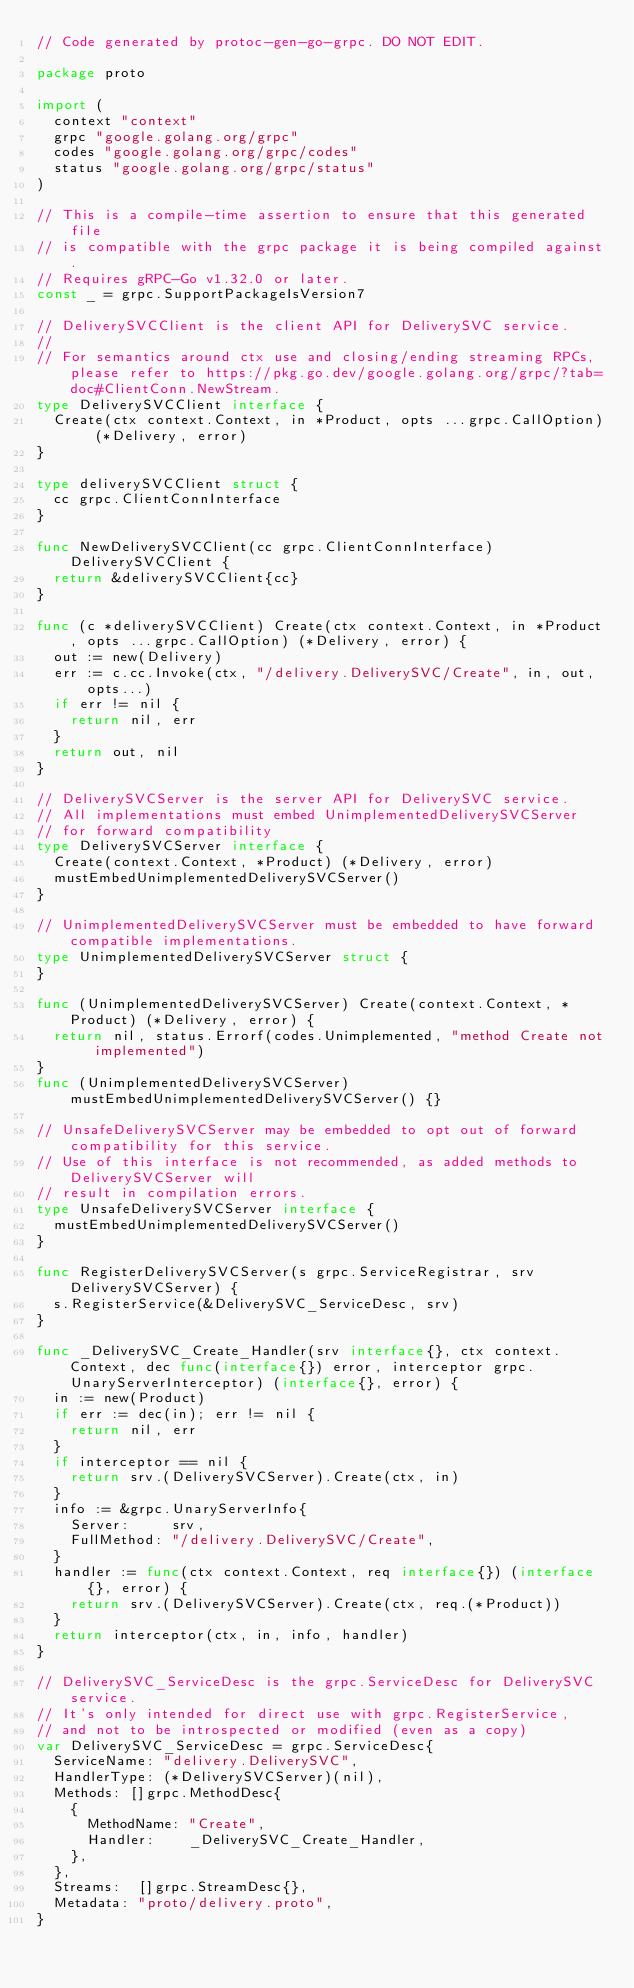Convert code to text. <code><loc_0><loc_0><loc_500><loc_500><_Go_>// Code generated by protoc-gen-go-grpc. DO NOT EDIT.

package proto

import (
	context "context"
	grpc "google.golang.org/grpc"
	codes "google.golang.org/grpc/codes"
	status "google.golang.org/grpc/status"
)

// This is a compile-time assertion to ensure that this generated file
// is compatible with the grpc package it is being compiled against.
// Requires gRPC-Go v1.32.0 or later.
const _ = grpc.SupportPackageIsVersion7

// DeliverySVCClient is the client API for DeliverySVC service.
//
// For semantics around ctx use and closing/ending streaming RPCs, please refer to https://pkg.go.dev/google.golang.org/grpc/?tab=doc#ClientConn.NewStream.
type DeliverySVCClient interface {
	Create(ctx context.Context, in *Product, opts ...grpc.CallOption) (*Delivery, error)
}

type deliverySVCClient struct {
	cc grpc.ClientConnInterface
}

func NewDeliverySVCClient(cc grpc.ClientConnInterface) DeliverySVCClient {
	return &deliverySVCClient{cc}
}

func (c *deliverySVCClient) Create(ctx context.Context, in *Product, opts ...grpc.CallOption) (*Delivery, error) {
	out := new(Delivery)
	err := c.cc.Invoke(ctx, "/delivery.DeliverySVC/Create", in, out, opts...)
	if err != nil {
		return nil, err
	}
	return out, nil
}

// DeliverySVCServer is the server API for DeliverySVC service.
// All implementations must embed UnimplementedDeliverySVCServer
// for forward compatibility
type DeliverySVCServer interface {
	Create(context.Context, *Product) (*Delivery, error)
	mustEmbedUnimplementedDeliverySVCServer()
}

// UnimplementedDeliverySVCServer must be embedded to have forward compatible implementations.
type UnimplementedDeliverySVCServer struct {
}

func (UnimplementedDeliverySVCServer) Create(context.Context, *Product) (*Delivery, error) {
	return nil, status.Errorf(codes.Unimplemented, "method Create not implemented")
}
func (UnimplementedDeliverySVCServer) mustEmbedUnimplementedDeliverySVCServer() {}

// UnsafeDeliverySVCServer may be embedded to opt out of forward compatibility for this service.
// Use of this interface is not recommended, as added methods to DeliverySVCServer will
// result in compilation errors.
type UnsafeDeliverySVCServer interface {
	mustEmbedUnimplementedDeliverySVCServer()
}

func RegisterDeliverySVCServer(s grpc.ServiceRegistrar, srv DeliverySVCServer) {
	s.RegisterService(&DeliverySVC_ServiceDesc, srv)
}

func _DeliverySVC_Create_Handler(srv interface{}, ctx context.Context, dec func(interface{}) error, interceptor grpc.UnaryServerInterceptor) (interface{}, error) {
	in := new(Product)
	if err := dec(in); err != nil {
		return nil, err
	}
	if interceptor == nil {
		return srv.(DeliverySVCServer).Create(ctx, in)
	}
	info := &grpc.UnaryServerInfo{
		Server:     srv,
		FullMethod: "/delivery.DeliverySVC/Create",
	}
	handler := func(ctx context.Context, req interface{}) (interface{}, error) {
		return srv.(DeliverySVCServer).Create(ctx, req.(*Product))
	}
	return interceptor(ctx, in, info, handler)
}

// DeliverySVC_ServiceDesc is the grpc.ServiceDesc for DeliverySVC service.
// It's only intended for direct use with grpc.RegisterService,
// and not to be introspected or modified (even as a copy)
var DeliverySVC_ServiceDesc = grpc.ServiceDesc{
	ServiceName: "delivery.DeliverySVC",
	HandlerType: (*DeliverySVCServer)(nil),
	Methods: []grpc.MethodDesc{
		{
			MethodName: "Create",
			Handler:    _DeliverySVC_Create_Handler,
		},
	},
	Streams:  []grpc.StreamDesc{},
	Metadata: "proto/delivery.proto",
}
</code> 